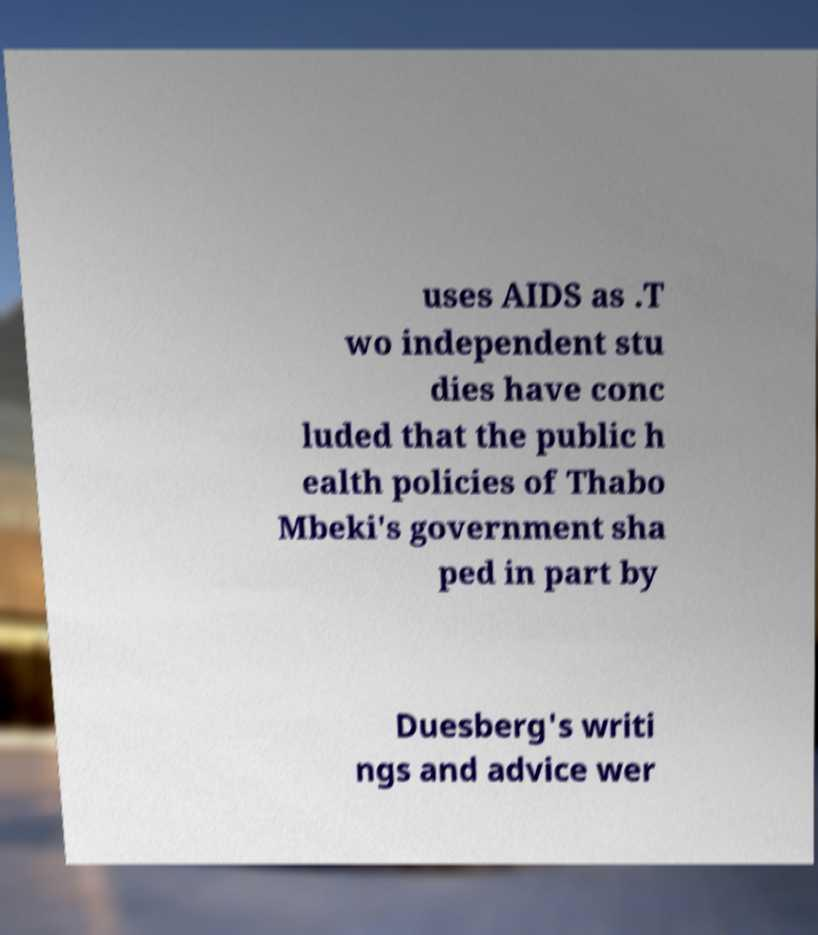What messages or text are displayed in this image? I need them in a readable, typed format. uses AIDS as .T wo independent stu dies have conc luded that the public h ealth policies of Thabo Mbeki's government sha ped in part by Duesberg's writi ngs and advice wer 